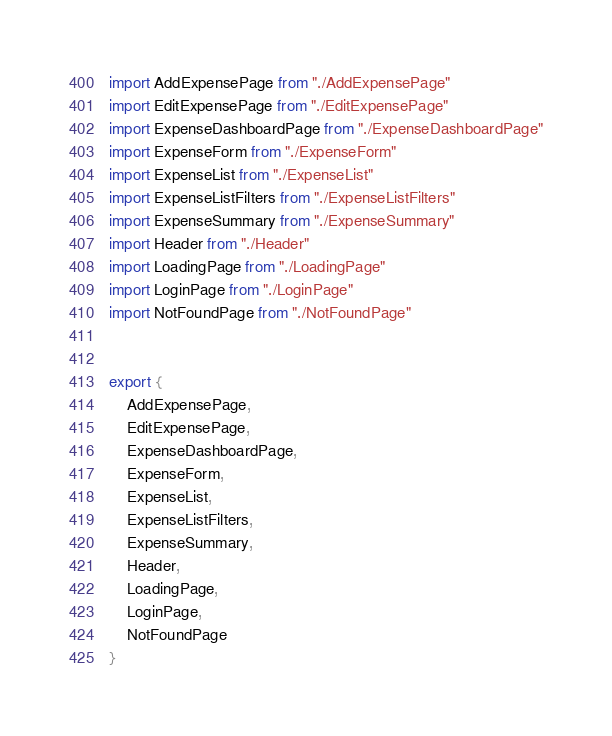<code> <loc_0><loc_0><loc_500><loc_500><_JavaScript_>import AddExpensePage from "./AddExpensePage"
import EditExpensePage from "./EditExpensePage"
import ExpenseDashboardPage from "./ExpenseDashboardPage"
import ExpenseForm from "./ExpenseForm"
import ExpenseList from "./ExpenseList"
import ExpenseListFilters from "./ExpenseListFilters"
import ExpenseSummary from "./ExpenseSummary"
import Header from "./Header"
import LoadingPage from "./LoadingPage"
import LoginPage from "./LoginPage"
import NotFoundPage from "./NotFoundPage"


export {
    AddExpensePage,
    EditExpensePage,
    ExpenseDashboardPage,
    ExpenseForm,
    ExpenseList,
    ExpenseListFilters,
    ExpenseSummary,
    Header,
    LoadingPage,
    LoginPage,
    NotFoundPage
}</code> 